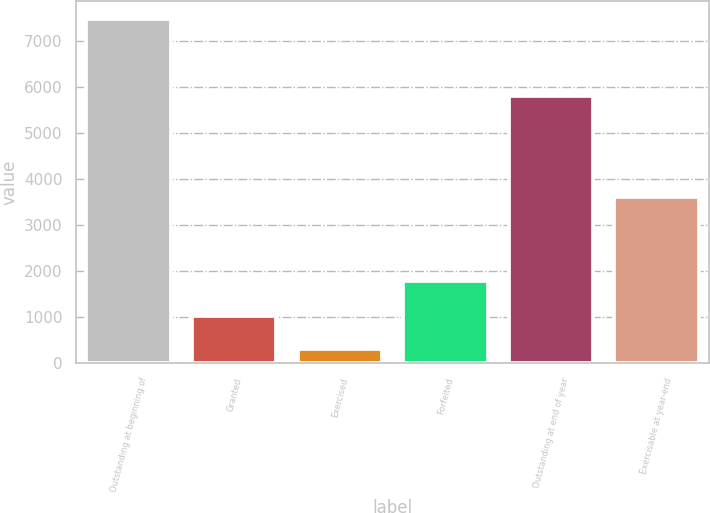<chart> <loc_0><loc_0><loc_500><loc_500><bar_chart><fcel>Outstanding at beginning of<fcel>Granted<fcel>Exercised<fcel>Forfeited<fcel>Outstanding at end of year<fcel>Exercisable at year-end<nl><fcel>7495<fcel>1024.9<fcel>306<fcel>1784<fcel>5802<fcel>3627<nl></chart> 